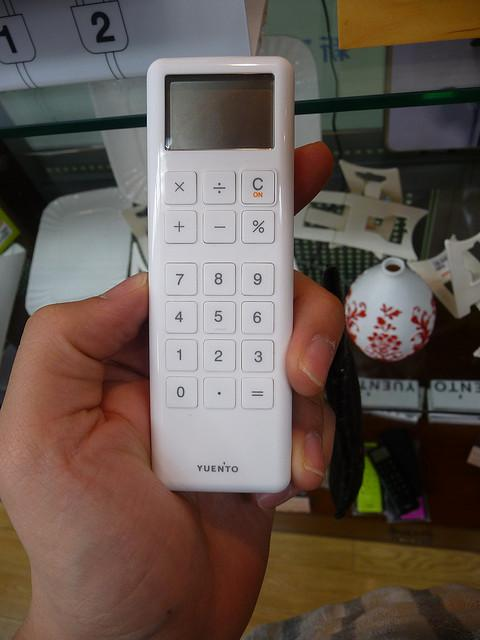What is this device used for? calculating 